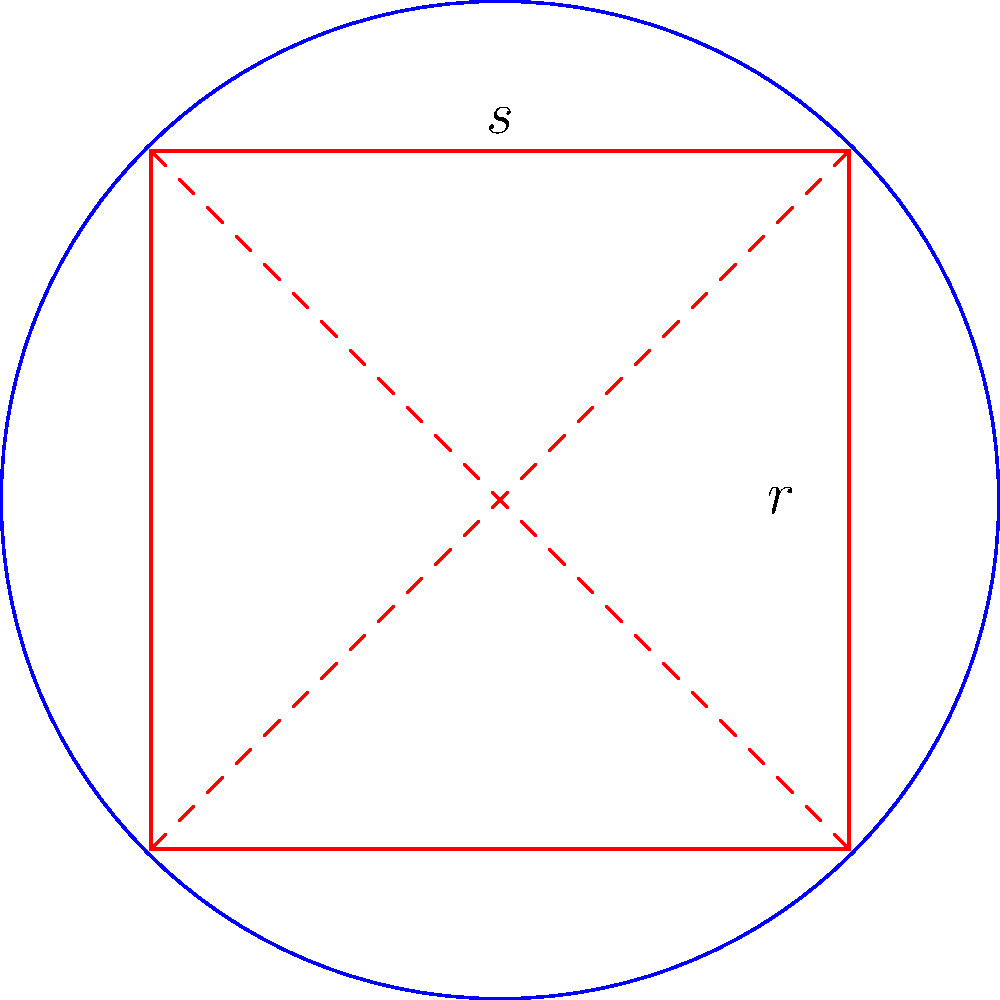A circular room has a radius of 5 meters. You want to tile the floor with square tiles, maximizing the covered area. If each tile measures 0.5 meters on each side, what is the maximum number of whole tiles that can fit within the circular room? To solve this problem, we need to follow these steps:

1) First, we need to find the largest square that can fit inside the circle. The diagonal of this square is equal to the diameter of the circle.

2) If $r$ is the radius of the circle and $s$ is the side length of the square, we can use the Pythagorean theorem:

   $s^2 + s^2 = (2r)^2$
   $2s^2 = 4r^2$
   $s^2 = 2r^2$
   $s = r\sqrt{2}$

3) Given $r = 5$ meters:
   $s = 5\sqrt{2} \approx 7.071$ meters

4) Now, we need to determine how many 0.5-meter tiles can fit along one side of this square:

   $7.071 \div 0.5 \approx 14.142$

   We round down to 14 tiles, as we can't use partial tiles.

5) The total number of tiles that can fit in the square is:

   $14 \times 14 = 196$ tiles

Therefore, the maximum number of whole 0.5-meter square tiles that can fit within the 5-meter radius circular room is 196.
Answer: 196 tiles 